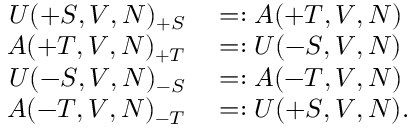Convert formula to latex. <formula><loc_0><loc_0><loc_500><loc_500>\begin{array} { r l } { U ( + S , V , N ) _ { + S } } & = \colon A ( + T , V , N ) } \\ { A ( + T , V , N ) _ { + T } } & = \colon U ( - S , V , N ) } \\ { U ( - S , V , N ) _ { - S } } & = \colon A ( - T , V , N ) } \\ { A ( - T , V , N ) _ { - T } } & = \colon U ( + S , V , N ) . } \end{array}</formula> 